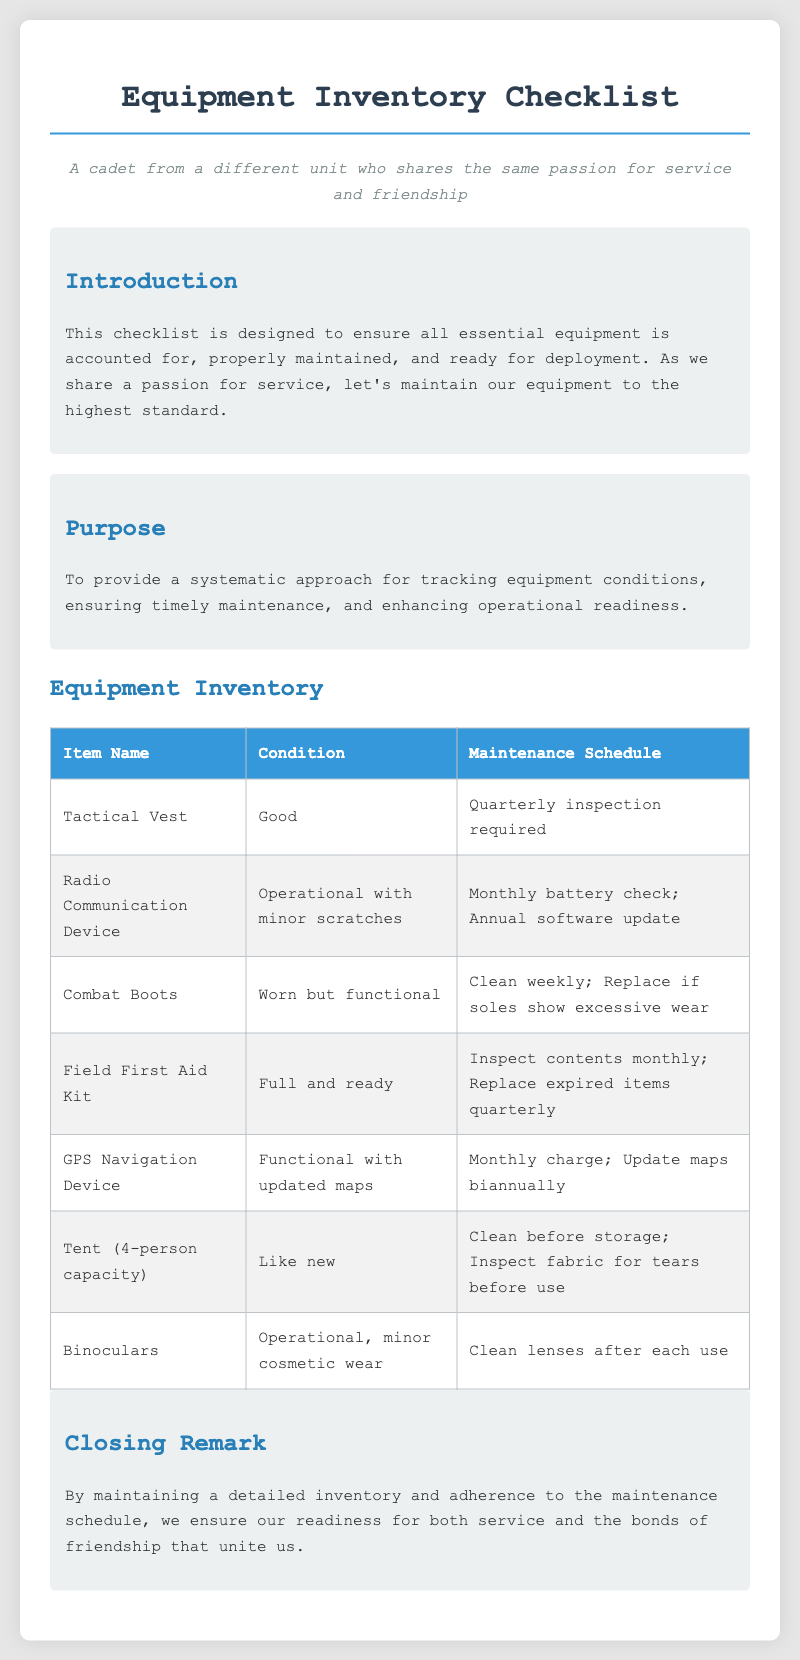what is the condition of the Tactical Vest? The condition of the Tactical Vest is stated as "Good" in the inventory checklist.
Answer: Good how often should the Radio Communication Device's battery be checked? The document specifies that a monthly battery check is required for the Radio Communication Device.
Answer: Monthly what maintenance is required for the Field First Aid Kit? The checklist indicates that the contents should be inspected monthly and expired items replaced quarterly.
Answer: Inspect contents monthly; Replace expired items quarterly how frequently should the GPS Navigation Device be charged? The maintenance section for the GPS Navigation Device states it should be charged monthly.
Answer: Monthly what is the condition of the Combat Boots? The condition of the Combat Boots is described as "Worn but functional" in the checklist.
Answer: Worn but functional what should be done to the Tent before storage? According to the checklist, the Tent should be cleaned before storage.
Answer: Clean before storage how often should the binoculars' lenses be cleaned? The document states that the lenses of the binoculars should be cleaned after each use.
Answer: After each use what is the purpose of this checklist? The document explains that the purpose is to provide a systematic approach for tracking equipment conditions and ensuring readiness.
Answer: Systematic approach for tracking equipment conditions and ensuring readiness 